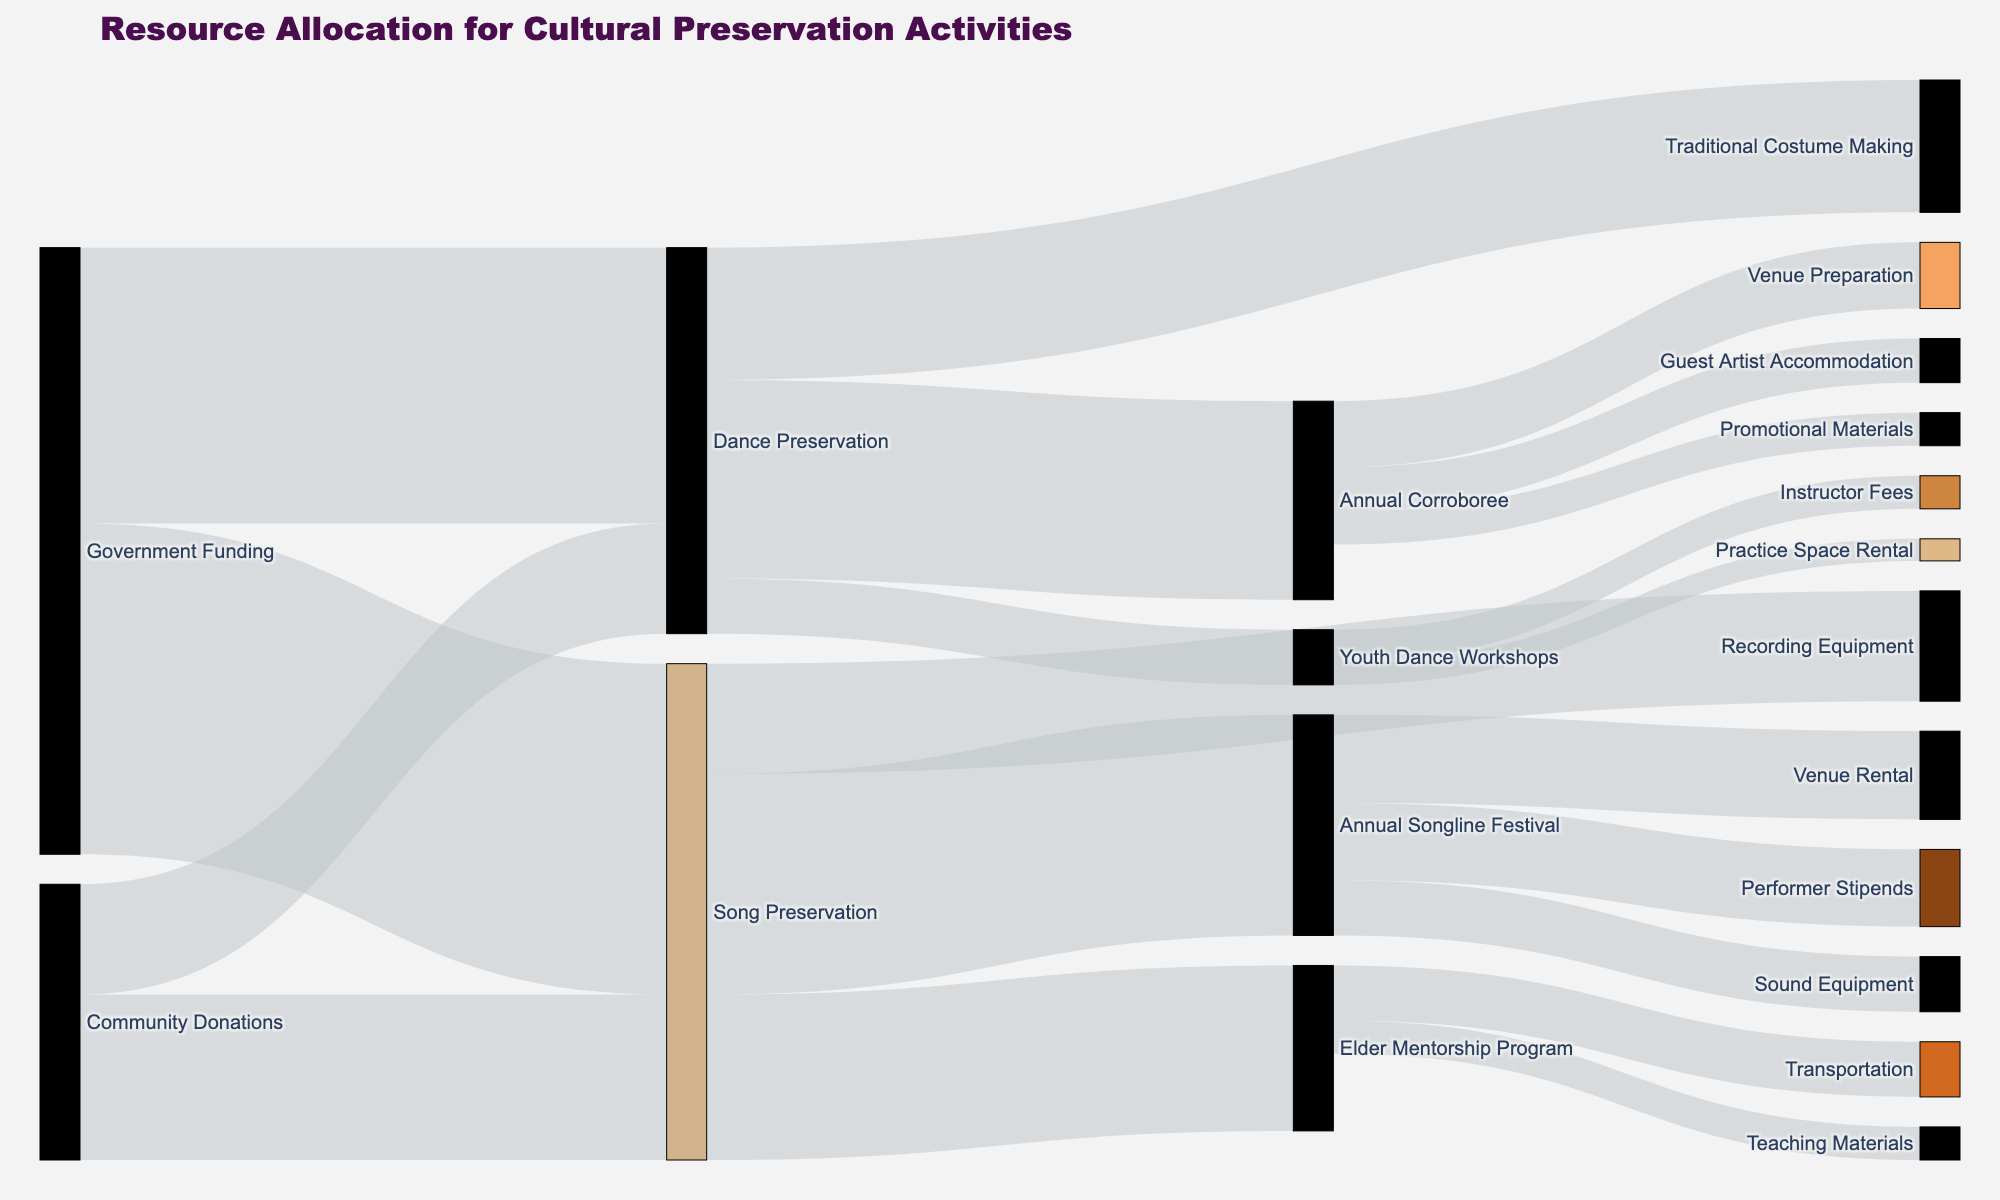What is the total amount of funding allocated by the Government for Song Preservation and Dance Preservation? The Government allocated $30,000 for Song Preservation and $25,000 for Dance Preservation. Adding them together gives $30,000 + $25,000 = $55,000.
Answer: $55,000 How much money did Community Donations contribute to cultural preservation activities in total? Community Donations allocated $15,000 to Song Preservation and $10,000 to Dance Preservation. Adding them together gives $15,000 + $10,000 = $25,000.
Answer: $25,000 Which activity within Song Preservation received the highest funding, and how much was it? The Annual Songline Festival received the highest funding under Song Preservation, with $20,000.
Answer: Annual Songline Festival, $20,000 Compare the funding for Traditional Costume Making and Youth Dance Workshops under Dance Preservation. Which one received more, and by how much? Traditional Costume Making received $12,000, while Youth Dance Workshops received $5,000. The difference is $12,000 - $5,000 = $7,000.
Answer: Traditional Costume Making, by $7,000 What is the total amount spent on all sub-activities under the Annual Songline Festival? The Annual Songline Festival funds were allocated to Venue Rental ($8,000), Performer Stipends ($7,000), and Sound Equipment ($5,000). Summing these gives $8,000 + $7,000 + $5,000 = $20,000.
Answer: $20,000 Which preservation activity has more total funding from all sources: Song Preservation or Dance Preservation? Adding the funding from all sources, Song Preservation has $30,000 (Government) + $15,000 (Community) = $45,000. Dance Preservation has $25,000 (Government) + $10,000 (Community) = $35,000. Song Preservation has more funding.
Answer: Song Preservation How much funding is allocated to the Youth Dance Workshops, and what are the specific sub-activities for this funding? Youth Dance Workshops received a total funding of $5,000. The sub-activities include Instructor Fees ($3,000) and Practice Space Rental ($2,000).
Answer: $5,000; Instructor Fees and Practice Space Rental What is the total amount spent specifically on Venue expenditures across all activities? Venue expenditures include Venue Rental for Annual Songline Festival ($8,000) and Venue Preparation for Annual Corroboree ($6,000). Adding these gives $8,000 + $6,000 = $14,000.
Answer: $14,000 